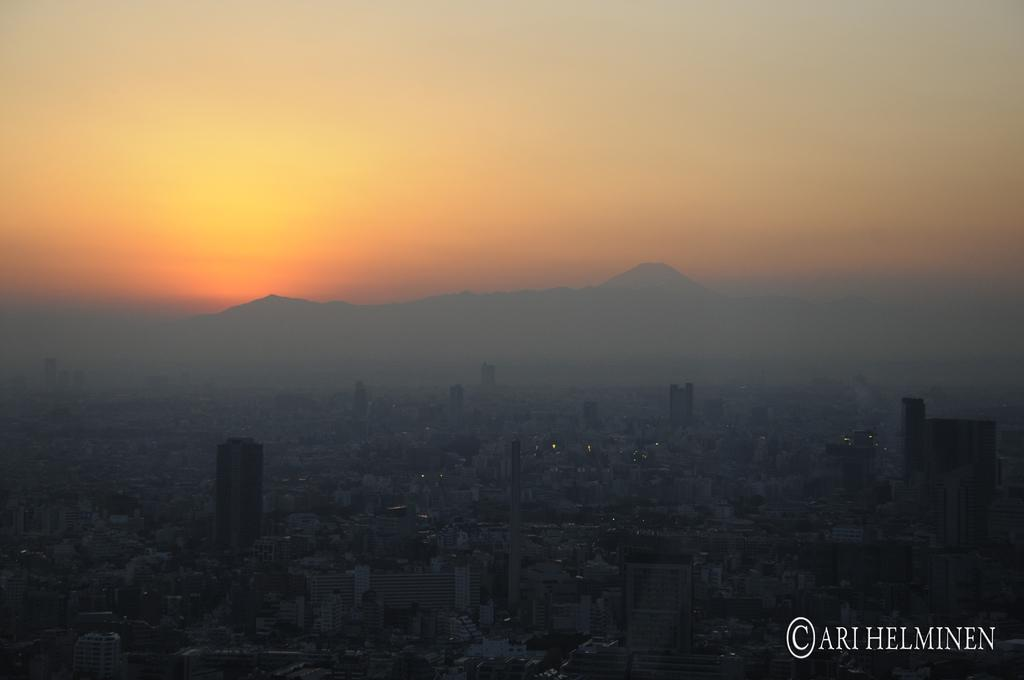What type of view is shown in the image? The image is an aerial view. What can be seen at the bottom of the image? There are many buildings visible at the bottom of the image. What is visible in the background of the image? There are hills and the sky visible in the background of the image. What type of sweater is being worn by the drum in the image? There is no sweater or drum present in the image; it is an aerial view of buildings, hills, and the sky. 